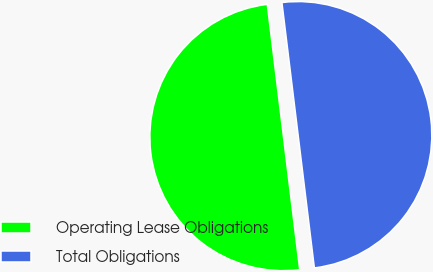Convert chart. <chart><loc_0><loc_0><loc_500><loc_500><pie_chart><fcel>Operating Lease Obligations<fcel>Total Obligations<nl><fcel>50.0%<fcel>50.0%<nl></chart> 